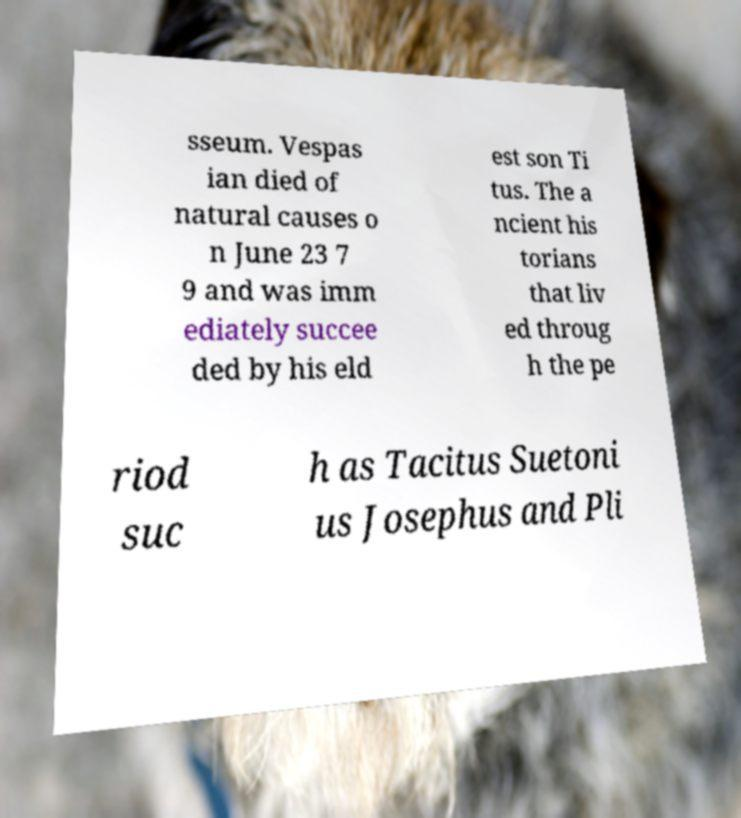Please read and relay the text visible in this image. What does it say? sseum. Vespas ian died of natural causes o n June 23 7 9 and was imm ediately succee ded by his eld est son Ti tus. The a ncient his torians that liv ed throug h the pe riod suc h as Tacitus Suetoni us Josephus and Pli 